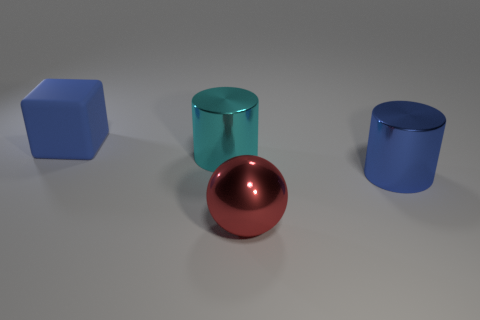How many large things are behind the large blue cylinder?
Your answer should be compact. 2. Are there an equal number of red shiny objects to the left of the large red metal ball and blue cylinders?
Offer a terse response. No. Do the large blue cylinder and the block have the same material?
Your answer should be very brief. No. There is a thing that is both left of the large sphere and right of the large cube; how big is it?
Offer a very short reply. Large. What number of other rubber cylinders have the same size as the cyan cylinder?
Your answer should be compact. 0. What is the size of the blue object that is behind the blue thing right of the big blue cube?
Keep it short and to the point. Large. Do the metallic object that is right of the red metal thing and the big thing that is left of the cyan metallic thing have the same shape?
Your answer should be very brief. No. There is a metal thing that is on the left side of the big blue metallic thing and behind the red metal ball; what is its color?
Give a very brief answer. Cyan. Is there a large metal sphere that has the same color as the big block?
Give a very brief answer. No. What is the color of the big metal object to the left of the large red object?
Ensure brevity in your answer.  Cyan. 